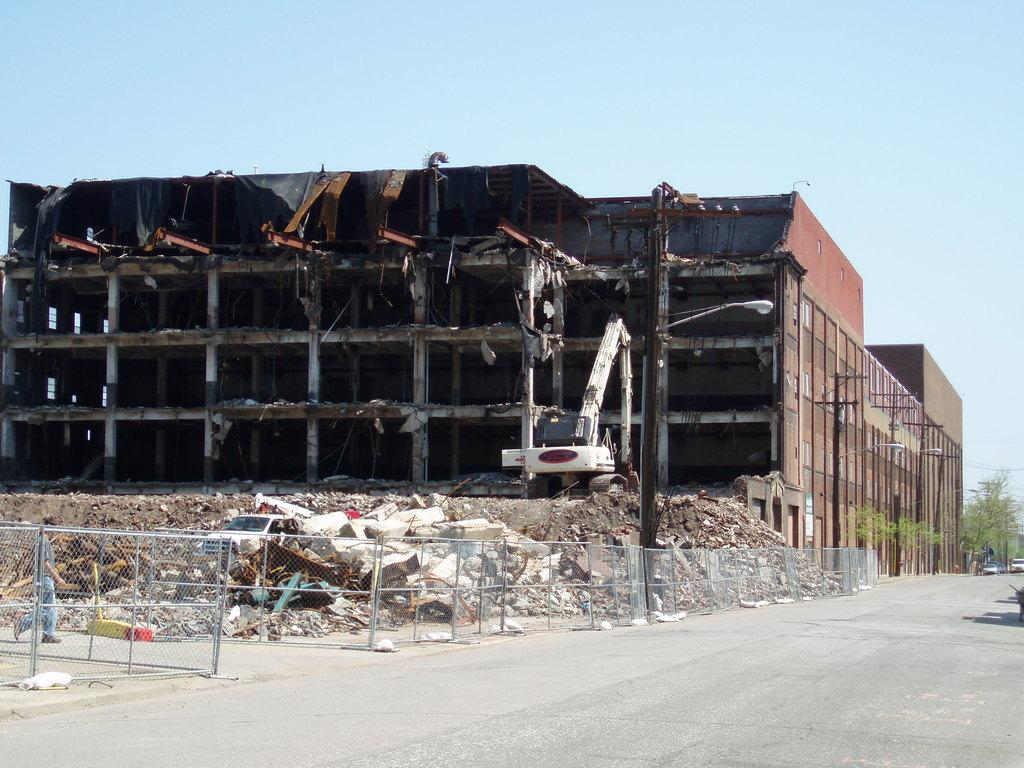What is the main object in the image? There is a machine in the image. What else can be seen in the image besides the machine? There is a building, trees, and cars in the image. Can you describe the condition of the building? The building appears to be under renovation. How many ladybugs can be seen on the machine in the image? There are no ladybugs present in the image. What type of knot is used to secure the building during renovation in the image? The image does not show any knots being used for the building's renovation. 